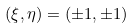<formula> <loc_0><loc_0><loc_500><loc_500>( \xi , \eta ) = ( \pm 1 , \pm 1 )</formula> 